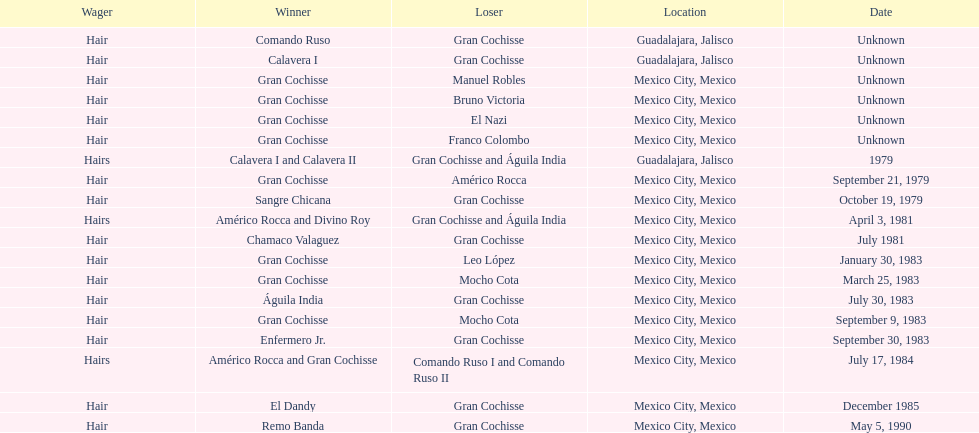How many more victories did sangre chicana have compared to chamaco valaguez? 0. 